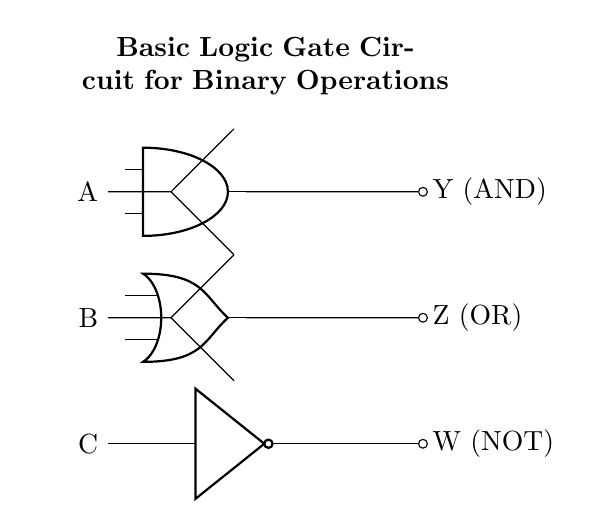What are the input variables for this circuit? The circuit has three input variables labeled A, B, and C. These are designated for the AND, OR, and NOT gates respectively.
Answer: A, B, C How many outputs does this circuit produce? There are three outputs from this circuit, which are denoted as Y (from the AND gate), Z (from the OR gate), and W (from the NOT gate).
Answer: Three What logic gates are present in the circuit? The circuit contains three types of logic gates: an AND gate, an OR gate, and a NOT gate. Each performs a different logical operation based on the inputs provided.
Answer: AND, OR, NOT What is the output of the AND gate labeled as? The output of the AND gate is labeled as Y and it is located at the top right side of the circuit diagram.
Answer: Y If both inputs A and B are true, what will be the output of the OR gate? The OR gate outputs true if at least one of its inputs is true. Since A and B are both true, the OR gate will output true as well.
Answer: True Which gate receives input from the variable C? The NOT gate receives input from the variable C, as indicated by the connection drawn from C to the NOT gate's input terminal.
Answer: NOT gate What happens if the input C is false? If input C is false, the NOT gate will output true because a NOT gate inverts the input it receives. Therefore, the output W will be true.
Answer: Output W is true 